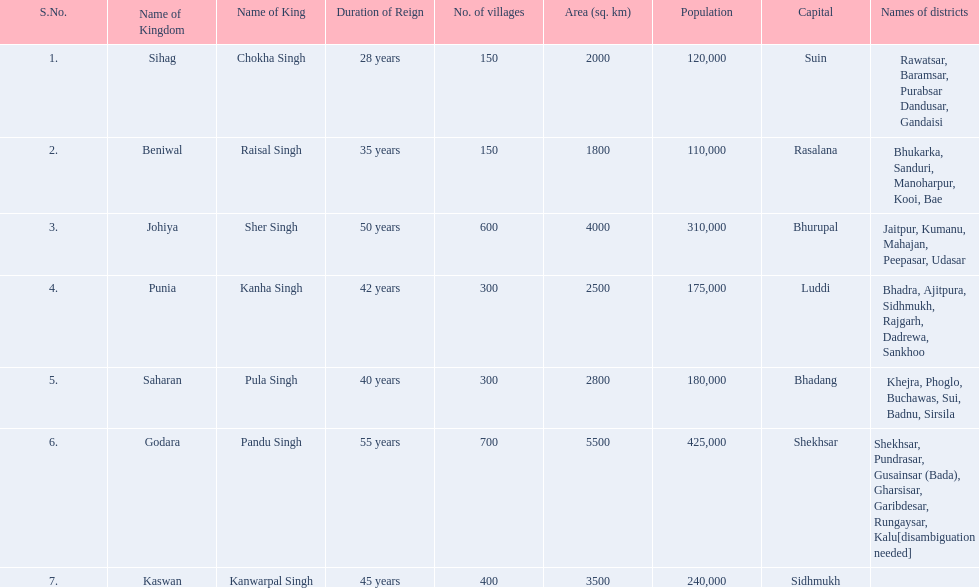Which kingdom contained the second most villages, next only to godara? Johiya. 